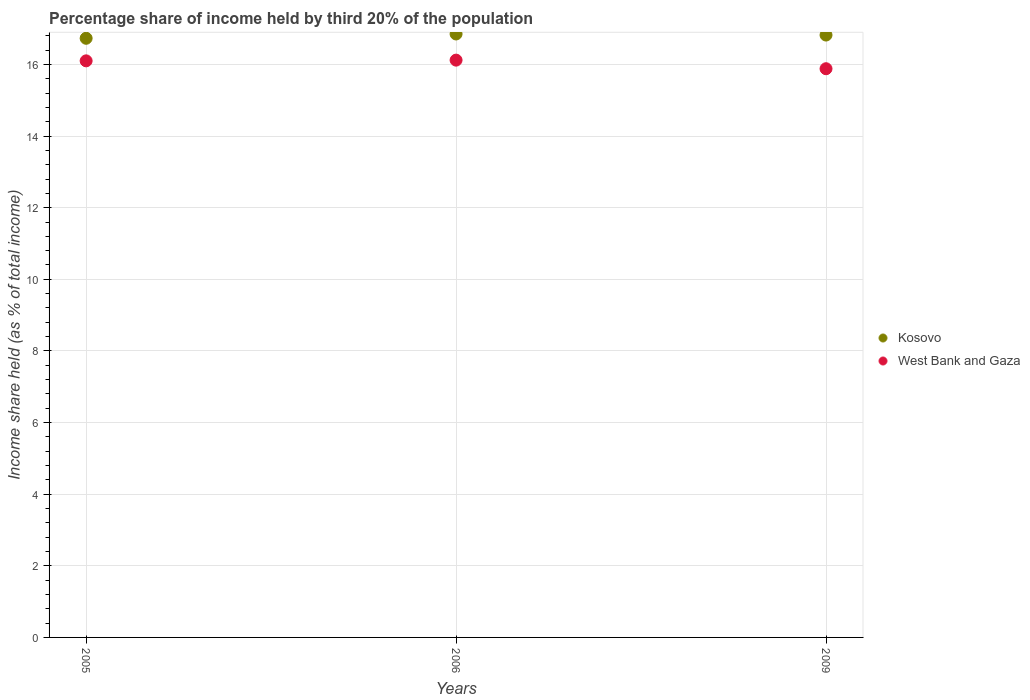Is the number of dotlines equal to the number of legend labels?
Offer a terse response. Yes. What is the share of income held by third 20% of the population in Kosovo in 2009?
Ensure brevity in your answer.  16.82. Across all years, what is the maximum share of income held by third 20% of the population in West Bank and Gaza?
Your answer should be very brief. 16.12. Across all years, what is the minimum share of income held by third 20% of the population in West Bank and Gaza?
Offer a very short reply. 15.88. In which year was the share of income held by third 20% of the population in West Bank and Gaza maximum?
Your answer should be very brief. 2006. What is the total share of income held by third 20% of the population in West Bank and Gaza in the graph?
Your answer should be very brief. 48.1. What is the difference between the share of income held by third 20% of the population in Kosovo in 2005 and that in 2009?
Your answer should be very brief. -0.09. What is the difference between the share of income held by third 20% of the population in West Bank and Gaza in 2005 and the share of income held by third 20% of the population in Kosovo in 2009?
Offer a very short reply. -0.72. What is the average share of income held by third 20% of the population in West Bank and Gaza per year?
Make the answer very short. 16.03. In the year 2006, what is the difference between the share of income held by third 20% of the population in West Bank and Gaza and share of income held by third 20% of the population in Kosovo?
Ensure brevity in your answer.  -0.73. What is the ratio of the share of income held by third 20% of the population in West Bank and Gaza in 2005 to that in 2006?
Ensure brevity in your answer.  1. What is the difference between the highest and the second highest share of income held by third 20% of the population in West Bank and Gaza?
Offer a very short reply. 0.02. What is the difference between the highest and the lowest share of income held by third 20% of the population in Kosovo?
Offer a terse response. 0.12. Is the sum of the share of income held by third 20% of the population in Kosovo in 2006 and 2009 greater than the maximum share of income held by third 20% of the population in West Bank and Gaza across all years?
Ensure brevity in your answer.  Yes. Does the share of income held by third 20% of the population in Kosovo monotonically increase over the years?
Provide a succinct answer. No. Is the share of income held by third 20% of the population in West Bank and Gaza strictly less than the share of income held by third 20% of the population in Kosovo over the years?
Make the answer very short. Yes. How many years are there in the graph?
Your answer should be compact. 3. What is the difference between two consecutive major ticks on the Y-axis?
Provide a short and direct response. 2. Are the values on the major ticks of Y-axis written in scientific E-notation?
Your answer should be compact. No. Does the graph contain any zero values?
Your answer should be compact. No. Where does the legend appear in the graph?
Provide a succinct answer. Center right. How many legend labels are there?
Provide a succinct answer. 2. How are the legend labels stacked?
Keep it short and to the point. Vertical. What is the title of the graph?
Keep it short and to the point. Percentage share of income held by third 20% of the population. Does "Morocco" appear as one of the legend labels in the graph?
Provide a succinct answer. No. What is the label or title of the Y-axis?
Ensure brevity in your answer.  Income share held (as % of total income). What is the Income share held (as % of total income) in Kosovo in 2005?
Keep it short and to the point. 16.73. What is the Income share held (as % of total income) of West Bank and Gaza in 2005?
Your answer should be very brief. 16.1. What is the Income share held (as % of total income) in Kosovo in 2006?
Offer a very short reply. 16.85. What is the Income share held (as % of total income) of West Bank and Gaza in 2006?
Offer a terse response. 16.12. What is the Income share held (as % of total income) of Kosovo in 2009?
Offer a very short reply. 16.82. What is the Income share held (as % of total income) of West Bank and Gaza in 2009?
Provide a short and direct response. 15.88. Across all years, what is the maximum Income share held (as % of total income) of Kosovo?
Ensure brevity in your answer.  16.85. Across all years, what is the maximum Income share held (as % of total income) of West Bank and Gaza?
Offer a very short reply. 16.12. Across all years, what is the minimum Income share held (as % of total income) of Kosovo?
Your answer should be very brief. 16.73. Across all years, what is the minimum Income share held (as % of total income) of West Bank and Gaza?
Your response must be concise. 15.88. What is the total Income share held (as % of total income) of Kosovo in the graph?
Your answer should be very brief. 50.4. What is the total Income share held (as % of total income) of West Bank and Gaza in the graph?
Provide a short and direct response. 48.1. What is the difference between the Income share held (as % of total income) in Kosovo in 2005 and that in 2006?
Your response must be concise. -0.12. What is the difference between the Income share held (as % of total income) in West Bank and Gaza in 2005 and that in 2006?
Offer a terse response. -0.02. What is the difference between the Income share held (as % of total income) of Kosovo in 2005 and that in 2009?
Provide a short and direct response. -0.09. What is the difference between the Income share held (as % of total income) of West Bank and Gaza in 2005 and that in 2009?
Your answer should be very brief. 0.22. What is the difference between the Income share held (as % of total income) of West Bank and Gaza in 2006 and that in 2009?
Make the answer very short. 0.24. What is the difference between the Income share held (as % of total income) of Kosovo in 2005 and the Income share held (as % of total income) of West Bank and Gaza in 2006?
Offer a very short reply. 0.61. What is the difference between the Income share held (as % of total income) in Kosovo in 2006 and the Income share held (as % of total income) in West Bank and Gaza in 2009?
Keep it short and to the point. 0.97. What is the average Income share held (as % of total income) in Kosovo per year?
Ensure brevity in your answer.  16.8. What is the average Income share held (as % of total income) of West Bank and Gaza per year?
Give a very brief answer. 16.03. In the year 2005, what is the difference between the Income share held (as % of total income) in Kosovo and Income share held (as % of total income) in West Bank and Gaza?
Your answer should be compact. 0.63. In the year 2006, what is the difference between the Income share held (as % of total income) of Kosovo and Income share held (as % of total income) of West Bank and Gaza?
Your answer should be very brief. 0.73. In the year 2009, what is the difference between the Income share held (as % of total income) in Kosovo and Income share held (as % of total income) in West Bank and Gaza?
Make the answer very short. 0.94. What is the ratio of the Income share held (as % of total income) of Kosovo in 2005 to that in 2006?
Keep it short and to the point. 0.99. What is the ratio of the Income share held (as % of total income) in West Bank and Gaza in 2005 to that in 2006?
Provide a short and direct response. 1. What is the ratio of the Income share held (as % of total income) in West Bank and Gaza in 2005 to that in 2009?
Offer a terse response. 1.01. What is the ratio of the Income share held (as % of total income) of Kosovo in 2006 to that in 2009?
Keep it short and to the point. 1. What is the ratio of the Income share held (as % of total income) in West Bank and Gaza in 2006 to that in 2009?
Keep it short and to the point. 1.02. What is the difference between the highest and the lowest Income share held (as % of total income) of Kosovo?
Your answer should be very brief. 0.12. What is the difference between the highest and the lowest Income share held (as % of total income) of West Bank and Gaza?
Provide a succinct answer. 0.24. 